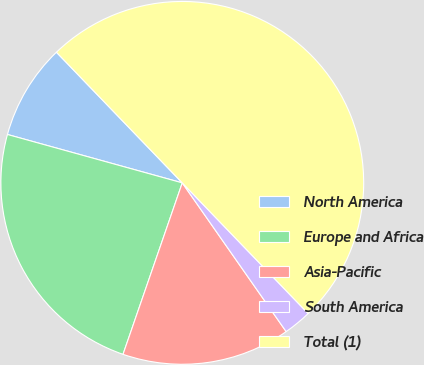<chart> <loc_0><loc_0><loc_500><loc_500><pie_chart><fcel>North America<fcel>Europe and Africa<fcel>Asia-Pacific<fcel>South America<fcel>Total (1)<nl><fcel>8.5%<fcel>24.0%<fcel>15.0%<fcel>2.5%<fcel>50.0%<nl></chart> 